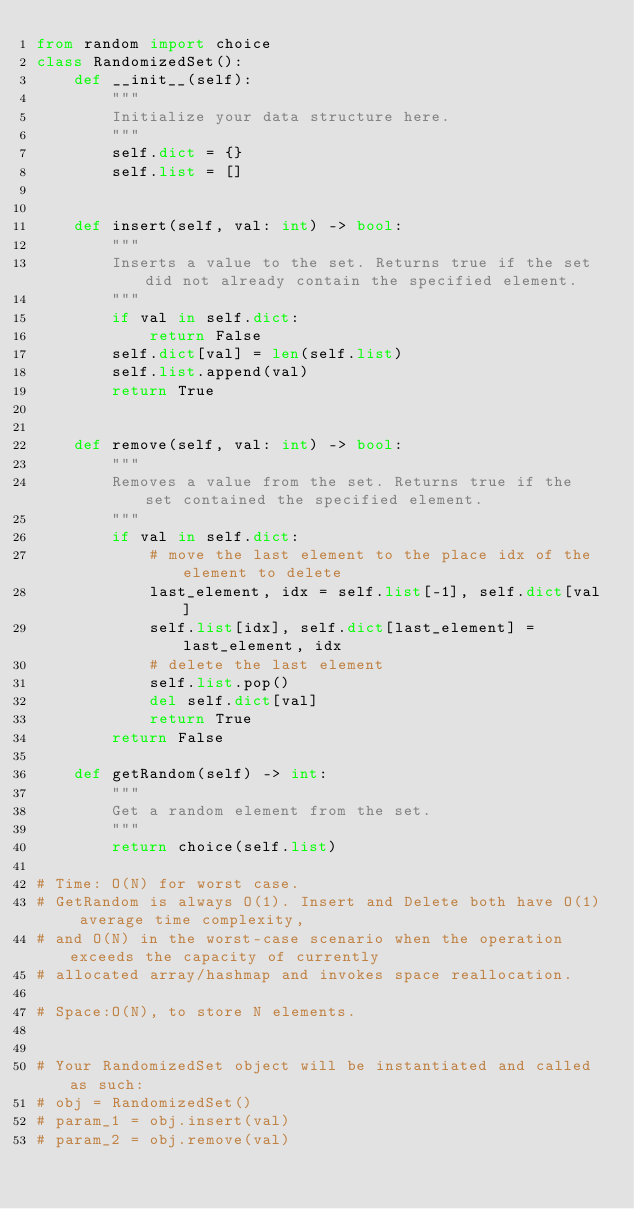<code> <loc_0><loc_0><loc_500><loc_500><_Python_>from random import choice
class RandomizedSet():
    def __init__(self):
        """
        Initialize your data structure here.
        """
        self.dict = {}
        self.list = []

        
    def insert(self, val: int) -> bool:
        """
        Inserts a value to the set. Returns true if the set did not already contain the specified element.
        """
        if val in self.dict:
            return False
        self.dict[val] = len(self.list)
        self.list.append(val)
        return True
        

    def remove(self, val: int) -> bool:
        """
        Removes a value from the set. Returns true if the set contained the specified element.
        """
        if val in self.dict:
            # move the last element to the place idx of the element to delete
            last_element, idx = self.list[-1], self.dict[val]
            self.list[idx], self.dict[last_element] = last_element, idx
            # delete the last element
            self.list.pop()
            del self.dict[val]
            return True
        return False

    def getRandom(self) -> int:
        """
        Get a random element from the set.
        """
        return choice(self.list)

# Time: O(N) for worst case. 
# GetRandom is always O(1). Insert and Delete both have O(1) average time complexity, 
# and O(N) in the worst-case scenario when the operation exceeds the capacity of currently 
# allocated array/hashmap and invokes space reallocation.

# Space:O(N), to store N elements.


# Your RandomizedSet object will be instantiated and called as such:
# obj = RandomizedSet()
# param_1 = obj.insert(val)
# param_2 = obj.remove(val)</code> 